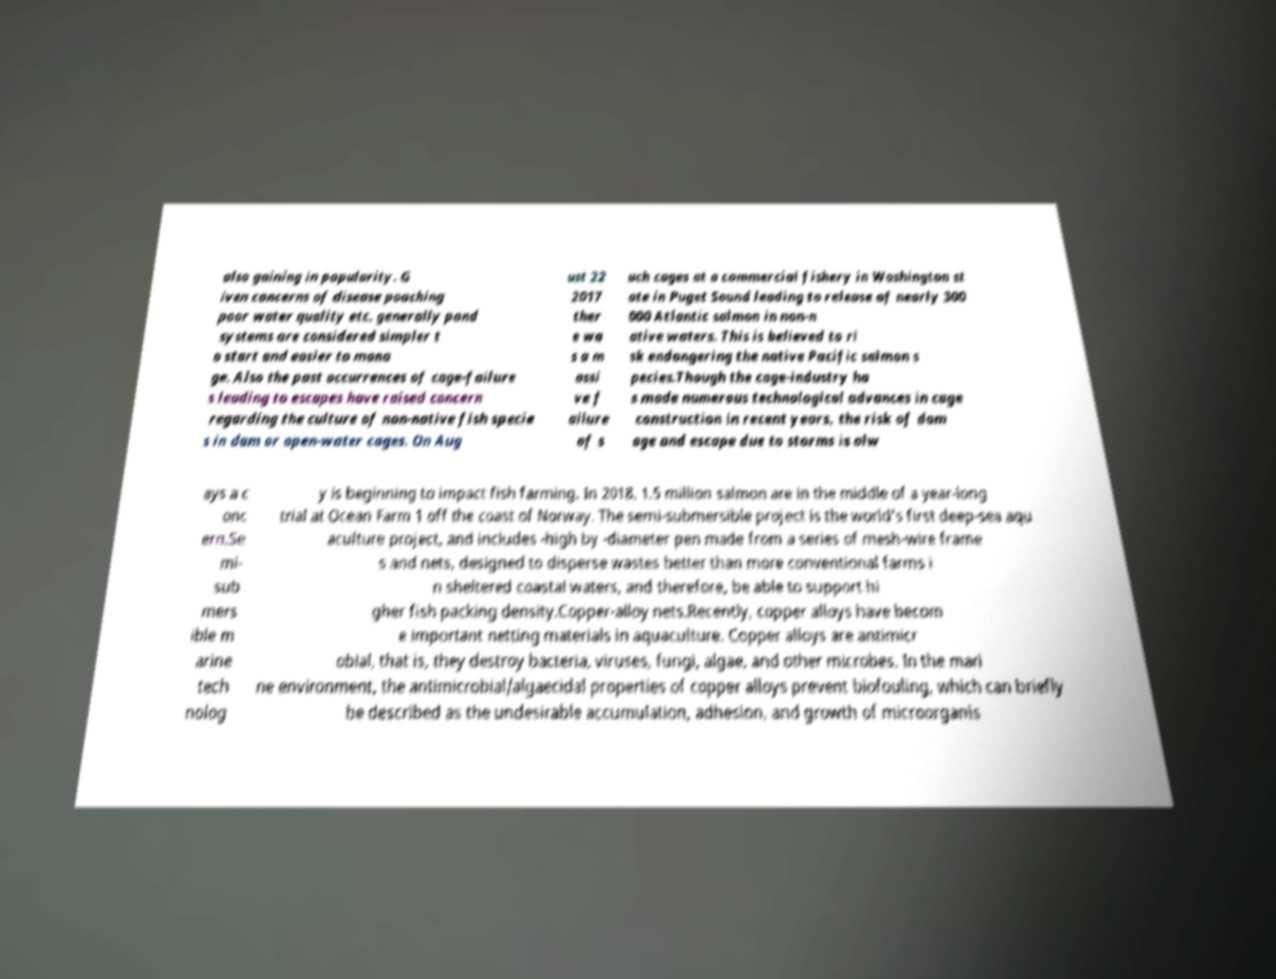Please read and relay the text visible in this image. What does it say? also gaining in popularity. G iven concerns of disease poaching poor water quality etc. generally pond systems are considered simpler t o start and easier to mana ge. Also the past occurrences of cage-failure s leading to escapes have raised concern regarding the culture of non-native fish specie s in dam or open-water cages. On Aug ust 22 2017 ther e wa s a m assi ve f ailure of s uch cages at a commercial fishery in Washington st ate in Puget Sound leading to release of nearly 300 000 Atlantic salmon in non-n ative waters. This is believed to ri sk endangering the native Pacific salmon s pecies.Though the cage-industry ha s made numerous technological advances in cage construction in recent years, the risk of dam age and escape due to storms is alw ays a c onc ern.Se mi- sub mers ible m arine tech nolog y is beginning to impact fish farming. In 2018, 1.5 million salmon are in the middle of a year-long trial at Ocean Farm 1 off the coast of Norway. The semi-submersible project is the world's first deep-sea aqu aculture project, and includes -high by -diameter pen made from a series of mesh-wire frame s and nets, designed to disperse wastes better than more conventional farms i n sheltered coastal waters, and therefore, be able to support hi gher fish packing density.Copper-alloy nets.Recently, copper alloys have becom e important netting materials in aquaculture. Copper alloys are antimicr obial, that is, they destroy bacteria, viruses, fungi, algae, and other microbes. In the mari ne environment, the antimicrobial/algaecidal properties of copper alloys prevent biofouling, which can briefly be described as the undesirable accumulation, adhesion, and growth of microorganis 